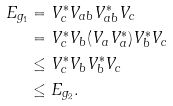Convert formula to latex. <formula><loc_0><loc_0><loc_500><loc_500>E _ { g _ { 1 } } & = V _ { c } ^ { * } V _ { a b } V _ { a b } ^ { * } V _ { c } \\ & = V _ { c } ^ { * } V _ { b } ( V _ { a } V _ { a } ^ { * } ) V _ { b } ^ { * } V _ { c } \\ & \leq V _ { c } ^ { * } V _ { b } V _ { b } ^ { * } V _ { c } \\ & \leq E _ { g _ { 2 } } .</formula> 